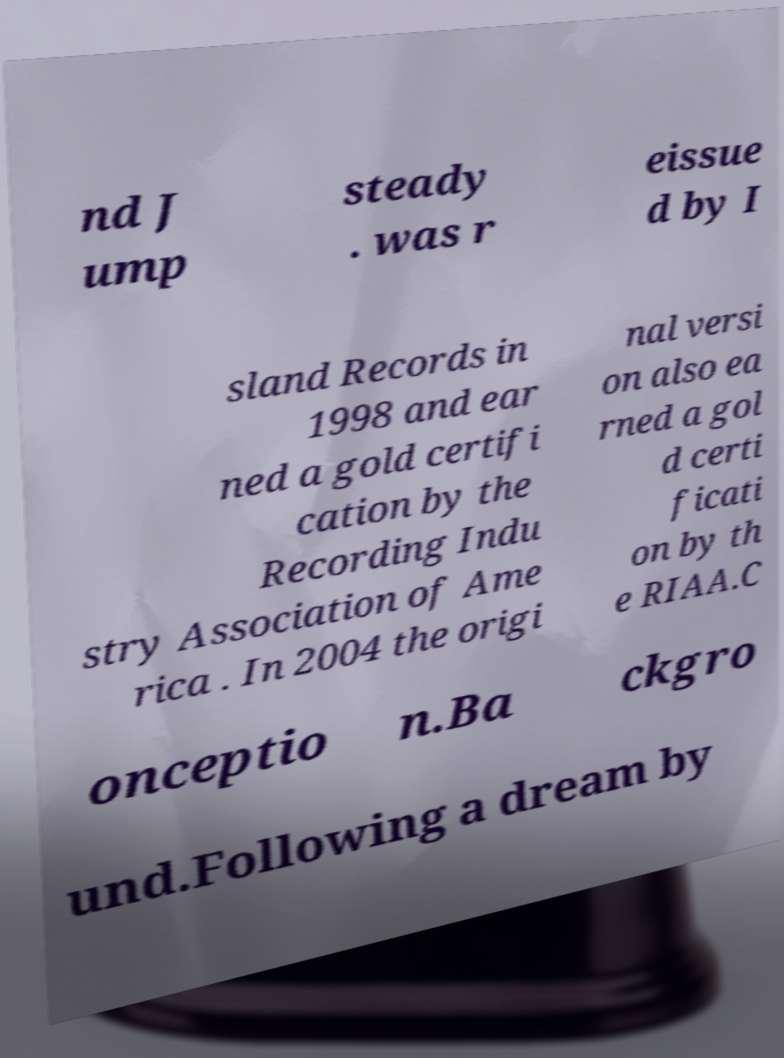Could you assist in decoding the text presented in this image and type it out clearly? nd J ump steady . was r eissue d by I sland Records in 1998 and ear ned a gold certifi cation by the Recording Indu stry Association of Ame rica . In 2004 the origi nal versi on also ea rned a gol d certi ficati on by th e RIAA.C onceptio n.Ba ckgro und.Following a dream by 